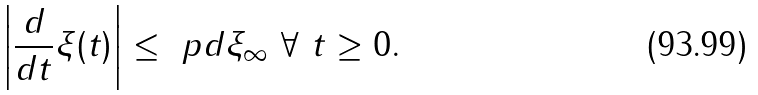<formula> <loc_0><loc_0><loc_500><loc_500>\left | \frac { d } { d t } \xi ( t ) \right | \leq \ p d \xi _ { \infty } \ \forall \ t \geq 0 .</formula> 